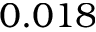<formula> <loc_0><loc_0><loc_500><loc_500>0 . 0 1 8</formula> 